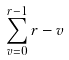<formula> <loc_0><loc_0><loc_500><loc_500>\sum _ { v = 0 } ^ { r - 1 } r - v</formula> 